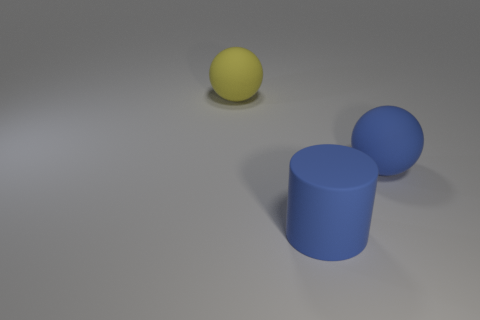The rubber sphere that is the same color as the rubber cylinder is what size?
Offer a terse response. Large. There is a rubber thing that is behind the blue cylinder and right of the big yellow rubber ball; what size is it?
Make the answer very short. Large. There is a large matte object that is left of the object in front of the big blue ball; what number of large things are in front of it?
Give a very brief answer. 2. Is there a small object that has the same color as the big cylinder?
Make the answer very short. No. There is another rubber ball that is the same size as the blue rubber ball; what is its color?
Your response must be concise. Yellow. The blue object that is in front of the matte ball in front of the thing that is behind the big blue rubber ball is what shape?
Provide a succinct answer. Cylinder. There is a big ball behind the blue ball; how many yellow objects are on the right side of it?
Provide a short and direct response. 0. There is a blue rubber object right of the blue rubber cylinder; is its shape the same as the large matte object to the left of the big cylinder?
Provide a succinct answer. Yes. There is a large yellow matte ball; how many large things are in front of it?
Provide a succinct answer. 2. Is the material of the big ball that is to the right of the large yellow rubber object the same as the yellow object?
Keep it short and to the point. Yes. 